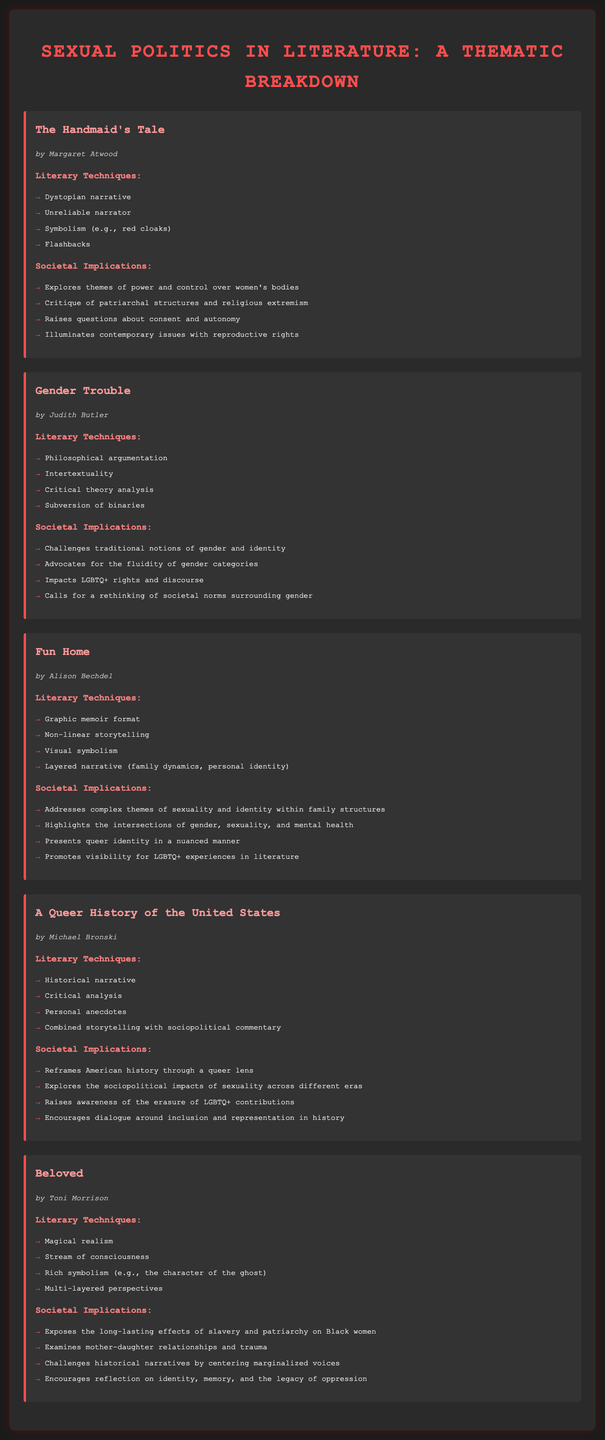What is the title of the first work mentioned? The first work mentioned in the document is the title of the section under "work", which is "The Handmaid's Tale".
Answer: The Handmaid's Tale Who is the author of "Gender Trouble"? The author listed for "Gender Trouble" in the document is specified under the author's name section.
Answer: Judith Butler What literary technique does "Fun Home" use for storytelling? The literary technique used in "Fun Home" is mentioned in the list, stating it uniquely employs a graphic memoir format.
Answer: Graphic memoir format What societal implication does "Beloved" address? The document lists various implications for "Beloved", one of which addresses the lasting effects of slavery on Black women.
Answer: Effects of slavery How many literary techniques are listed for "A Queer History of the United States"? The document includes a list of literary techniques for each work; for "A Queer History of the United States", there are four techniques mentioned.
Answer: Four Which color scheme is used for the headings in the document? The document describes the color styling for the headings, which are represented in various shades of red.
Answer: Red What narrative style is used in "The Handmaid's Tale"? The narrative style used in "The Handmaid's Tale" is specifically categorized in the document.
Answer: Dystopian narrative Which societal implication connects "Fun Home" and mental health? The document lists an implication that highlights the intersection of gender, sexuality, and mental health in "Fun Home".
Answer: Mental health What is the literary technique that involves intertextuality in "Gender Trouble"? Intertextuality is categorized under the literary techniques for "Gender Trouble" in the document.
Answer: Intertextuality 